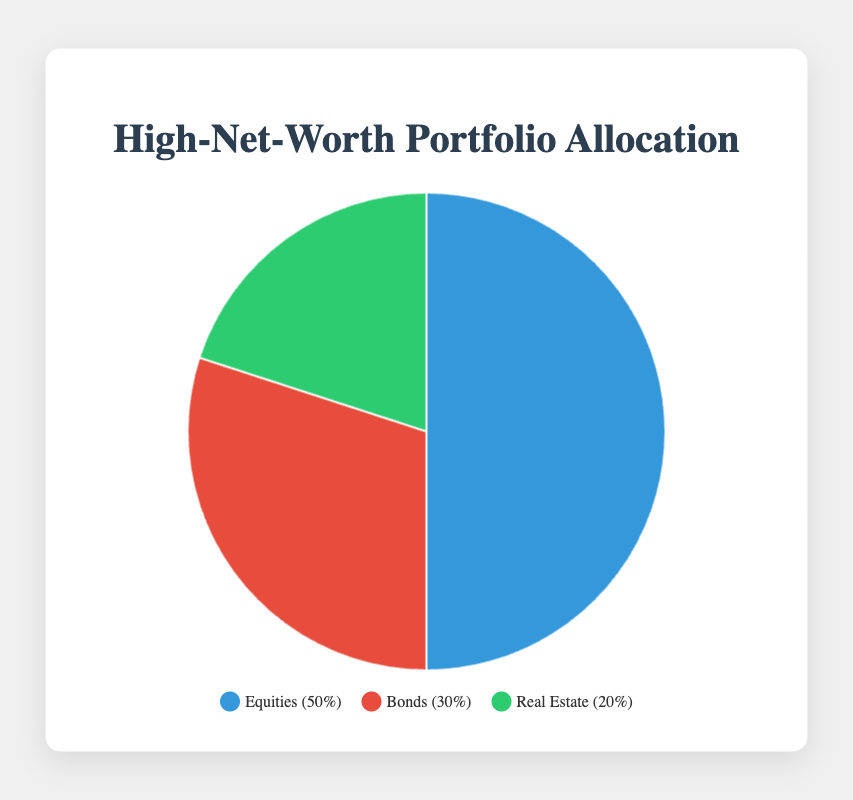What is the percentage allocation for Equities in my portfolio? From the pie chart, we see that the Equities segment takes up 50% of the entire pie.
Answer: 50% How much more is allocated to Equities compared to Real Estate? The allocation for Equities is 50%, while Real Estate is 20%. The difference in their allocation is 50% - 20% = 30%.
Answer: 30% What is the combined allocation of Bonds and Real Estate? Bonds are allocated 30% and Real Estate 20%. Adding these together, we get 30% + 20% = 50%.
Answer: 50% Which category has the smallest allocation in my portfolio? From the pie chart, Real Estate, at 20%, has the smallest allocation.
Answer: Real Estate Compare the allocation for Bonds and Equities in terms of percentage. The allocation for Bonds is 30%, and for Equities, it is 50%. Therefore, Equities have a higher allocation compared to Bonds.
Answer: Equities have a higher allocation than Bonds Describe the color used for the Real Estate segment in the pie chart. In the chart, Real Estate is depicted in green.
Answer: Green Which investment category contains entities like Apple Inc. and Tesla Inc.? The Equities segment includes entities such as Apple Inc. and Tesla Inc.
Answer: Equities What percentage of the portfolio is allocated to investment categories other than Equities? Equities occupy 50% of the portfolio. Thus, the remaining allocation for Bonds and Real Estate together is 100% - 50% = 50%.
Answer: 50% 